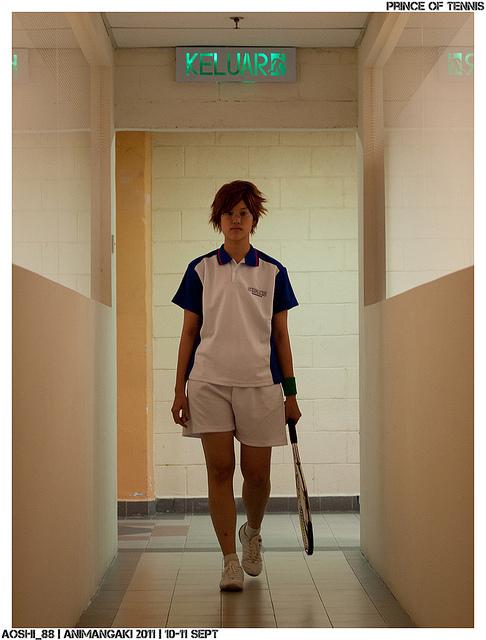What is the floor made of?
Give a very brief answer. Tile. Which hand is holding the racket?
Keep it brief. Left. What game does this person play?
Short answer required. Tennis. What is she holding in her left hand?
Short answer required. Racket. What year was this taken?
Short answer required. 2011. 